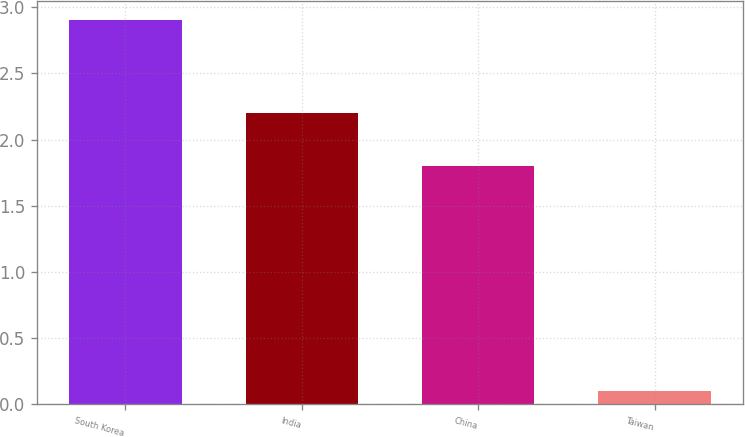Convert chart. <chart><loc_0><loc_0><loc_500><loc_500><bar_chart><fcel>South Korea<fcel>India<fcel>China<fcel>Taiwan<nl><fcel>2.9<fcel>2.2<fcel>1.8<fcel>0.1<nl></chart> 